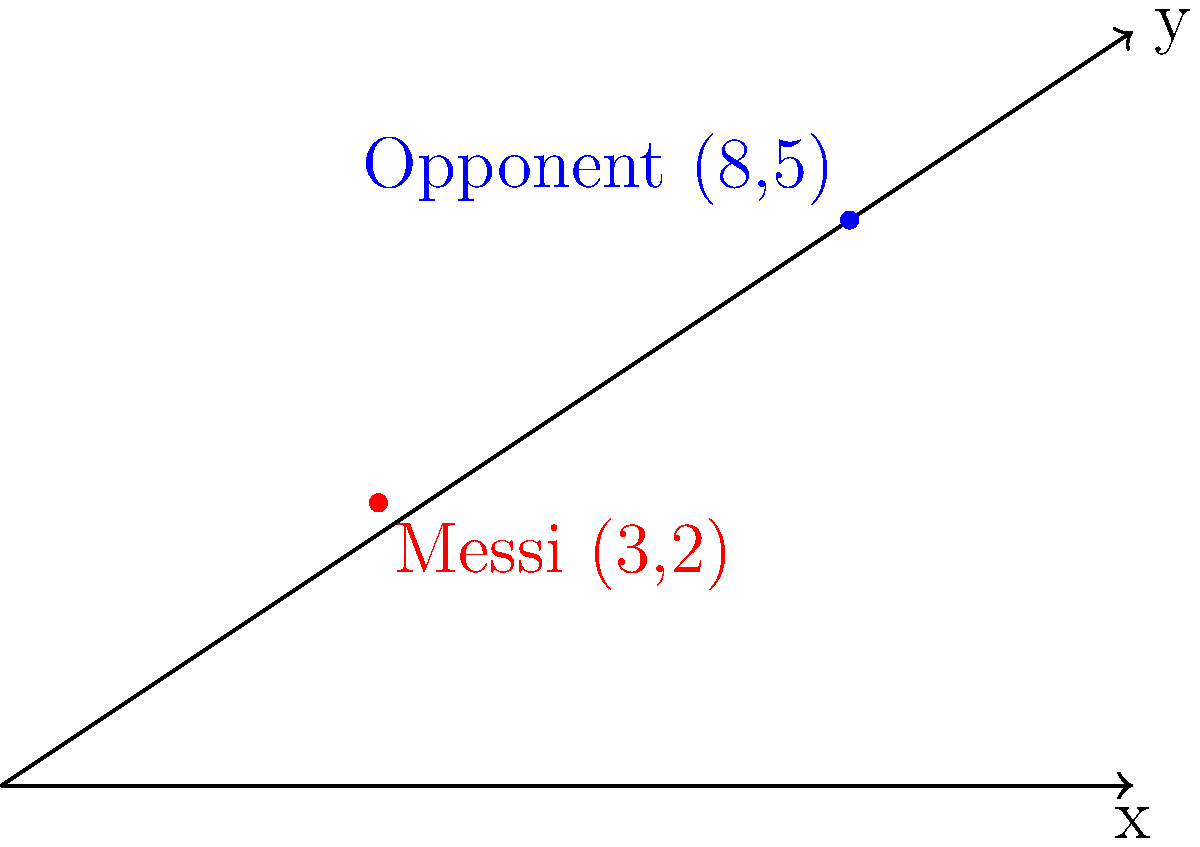In a crucial Champions League match, Lionel Messi is positioned at coordinates (3,2) on the pitch, while an opponent player is at (8,5). Using the distance formula, calculate the distance between Messi and the opponent player to the nearest tenth of a unit. To solve this problem, we'll use the distance formula:

$$d = \sqrt{(x_2 - x_1)^2 + (y_2 - y_1)^2}$$

Where:
$(x_1, y_1)$ is Messi's position (3,2)
$(x_2, y_2)$ is the opponent's position (8,5)

Let's substitute these values into the formula:

$$\begin{align}
d &= \sqrt{(8 - 3)^2 + (5 - 2)^2} \\
&= \sqrt{5^2 + 3^2} \\
&= \sqrt{25 + 9} \\
&= \sqrt{34} \\
&\approx 5.83
\end{align}$$

Rounding to the nearest tenth, we get 5.8 units.
Answer: 5.8 units 